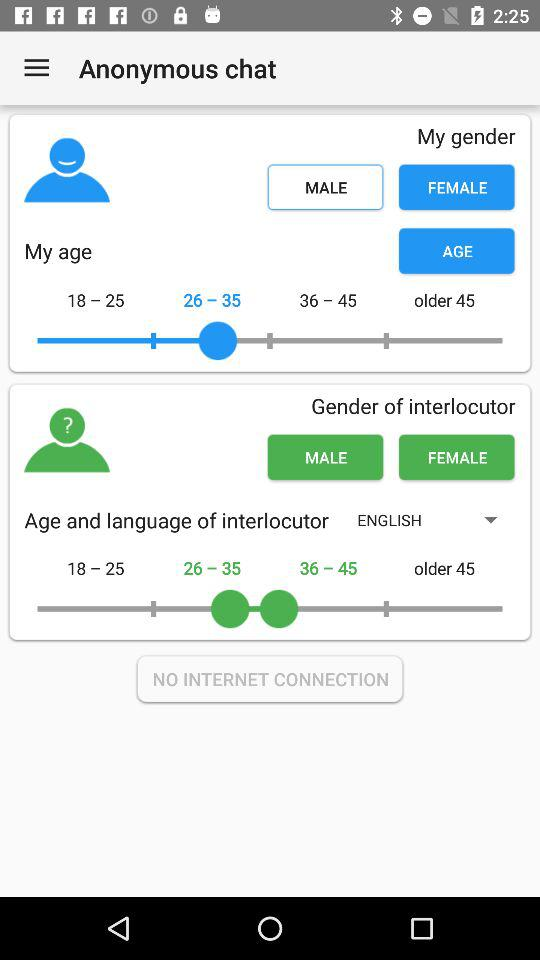What is the age selected for the interlocutor? The selected ages are 26 to 35 and 36 to 45. 